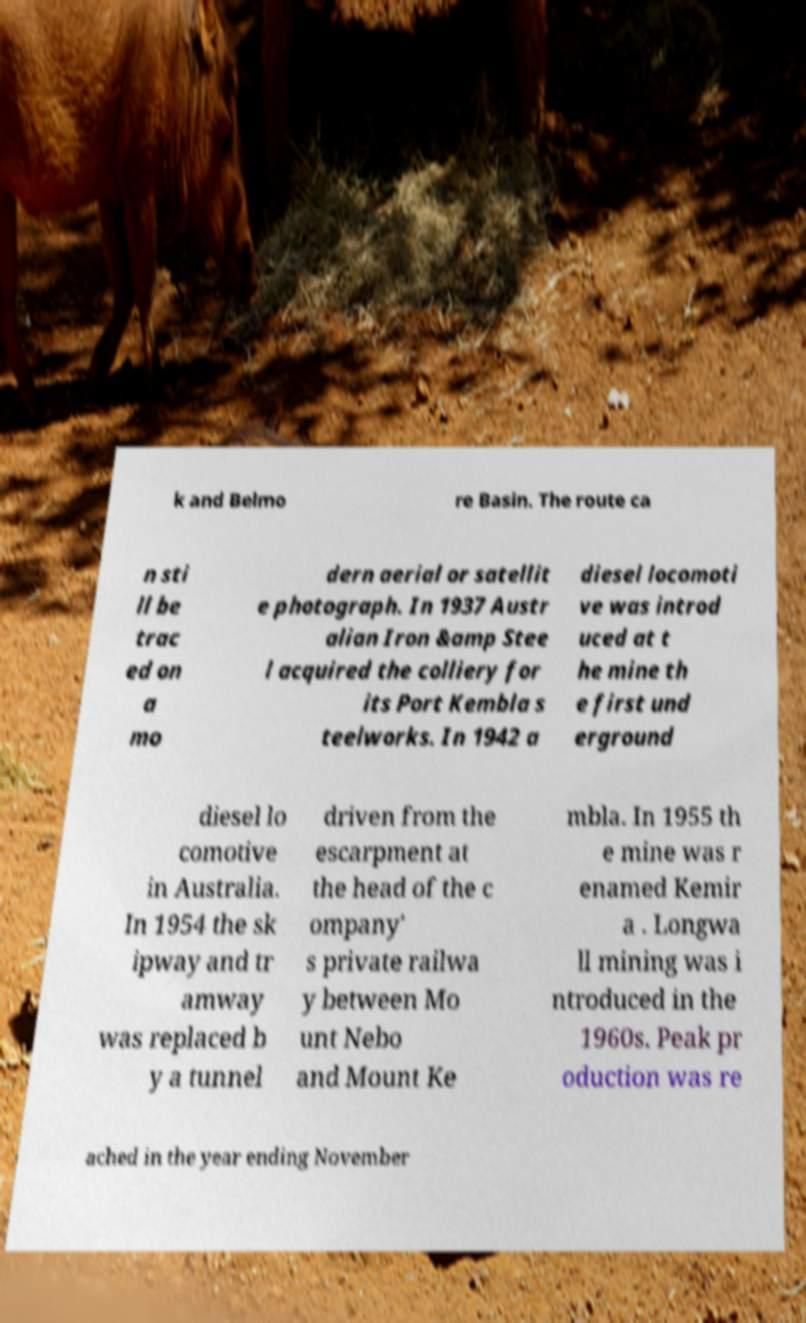Could you extract and type out the text from this image? k and Belmo re Basin. The route ca n sti ll be trac ed on a mo dern aerial or satellit e photograph. In 1937 Austr alian Iron &amp Stee l acquired the colliery for its Port Kembla s teelworks. In 1942 a diesel locomoti ve was introd uced at t he mine th e first und erground diesel lo comotive in Australia. In 1954 the sk ipway and tr amway was replaced b y a tunnel driven from the escarpment at the head of the c ompany' s private railwa y between Mo unt Nebo and Mount Ke mbla. In 1955 th e mine was r enamed Kemir a . Longwa ll mining was i ntroduced in the 1960s. Peak pr oduction was re ached in the year ending November 